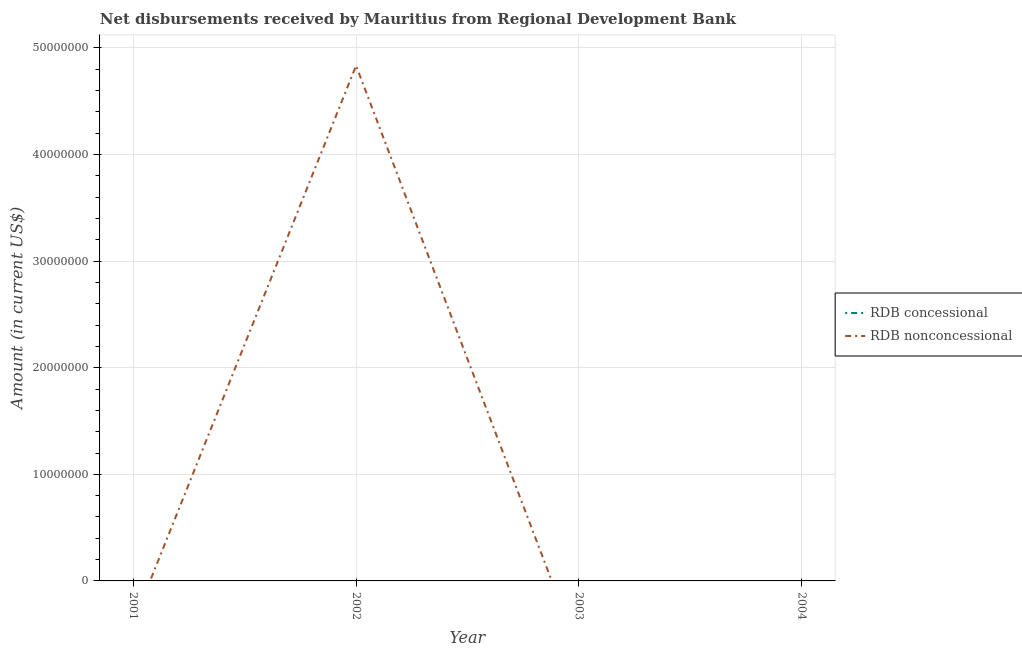How many different coloured lines are there?
Provide a short and direct response. 1. Does the line corresponding to net concessional disbursements from rdb intersect with the line corresponding to net non concessional disbursements from rdb?
Offer a terse response. Yes. Across all years, what is the maximum net non concessional disbursements from rdb?
Provide a short and direct response. 4.83e+07. In which year was the net non concessional disbursements from rdb maximum?
Your response must be concise. 2002. What is the total net non concessional disbursements from rdb in the graph?
Offer a terse response. 4.83e+07. What is the average net concessional disbursements from rdb per year?
Keep it short and to the point. 0. In how many years, is the net non concessional disbursements from rdb greater than 38000000 US$?
Your response must be concise. 1. What is the difference between the highest and the lowest net non concessional disbursements from rdb?
Keep it short and to the point. 4.83e+07. Does the net concessional disbursements from rdb monotonically increase over the years?
Your answer should be very brief. No. How many lines are there?
Your response must be concise. 1. What is the difference between two consecutive major ticks on the Y-axis?
Provide a succinct answer. 1.00e+07. Are the values on the major ticks of Y-axis written in scientific E-notation?
Give a very brief answer. No. Does the graph contain any zero values?
Give a very brief answer. Yes. Does the graph contain grids?
Offer a terse response. Yes. Where does the legend appear in the graph?
Keep it short and to the point. Center right. How are the legend labels stacked?
Offer a terse response. Vertical. What is the title of the graph?
Make the answer very short. Net disbursements received by Mauritius from Regional Development Bank. What is the label or title of the X-axis?
Your answer should be compact. Year. What is the label or title of the Y-axis?
Offer a terse response. Amount (in current US$). What is the Amount (in current US$) in RDB nonconcessional in 2002?
Give a very brief answer. 4.83e+07. What is the Amount (in current US$) in RDB nonconcessional in 2004?
Give a very brief answer. 0. Across all years, what is the maximum Amount (in current US$) in RDB nonconcessional?
Ensure brevity in your answer.  4.83e+07. Across all years, what is the minimum Amount (in current US$) in RDB nonconcessional?
Keep it short and to the point. 0. What is the total Amount (in current US$) of RDB nonconcessional in the graph?
Provide a short and direct response. 4.83e+07. What is the average Amount (in current US$) in RDB concessional per year?
Your answer should be very brief. 0. What is the average Amount (in current US$) of RDB nonconcessional per year?
Provide a succinct answer. 1.21e+07. What is the difference between the highest and the lowest Amount (in current US$) of RDB nonconcessional?
Ensure brevity in your answer.  4.83e+07. 